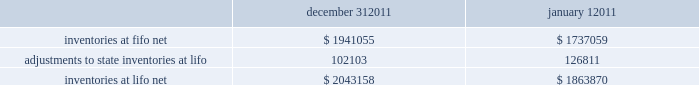Advance auto parts , inc .
And subsidiaries notes to the consolidated financial statements december 31 , 2011 , january 1 , 2011 and january 2 , 2010 ( in thousands , except per share data ) 2011-12 superseded certain pending paragraphs in asu 2011-05 201ccomprehensive income 2013 presentation of comprehensive income 201d to effectively defer only those changes in asu 2011-05 that related to the presentation of reclassification adjustments out of accumulated other comprehensive income .
The adoption of asu 2011-05 is not expected to have a material impact on the company 2019s consolidated financial condition , results of operations or cash flows .
In january 2010 , the fasb issued asu no .
2010-06 201cfair value measurements and disclosures 2013 improving disclosures about fair value measurements . 201d asu 2010-06 requires new disclosures for significant transfers in and out of level 1 and 2 of the fair value hierarchy and the activity within level 3 of the fair value hierarchy .
The updated guidance also clarifies existing disclosures regarding the level of disaggregation of assets or liabilities and the valuation techniques and inputs used to measure fair value .
The updated guidance is effective for interim and annual reporting periods beginning after december 15 , 2009 , with the exception of the new level 3 activity disclosures , which are effective for interim and annual reporting periods beginning after december 15 , 2010 .
The adoption of asu 2010-06 had no impact on the company 2019s consolidated financial condition , results of operations or cash flows .
Inventories , net : merchandise inventory the company used the lifo method of accounting for approximately 95% ( 95 % ) of inventories at december 31 , 2011 and january 1 , 2011 .
Under lifo , the company 2019s cost of sales reflects the costs of the most recently purchased inventories , while the inventory carrying balance represents the costs for inventories purchased in fiscal 2011 and prior years .
As a result of utilizing lifo , the company recorded an increase to cost of sales of $ 24708 for fiscal 2011 due to an increase in supply chain costs and inflationary pressures affecting certain product categories .
The company recorded a reduction to cost of sales of $ 29554 and $ 16040 for fiscal 2010 and 2009 , respectively .
Prior to fiscal 2011 , the company 2019s overall costs to acquire inventory for the same or similar products generally decreased historically as the company has been able to leverage its continued growth , execution of merchandise strategies and realization of supply chain efficiencies .
Product cores the remaining inventories are comprised of product cores , the non-consumable portion of certain parts and batteries , which are valued under the first-in , first-out ( "fifo" ) method .
Product cores are included as part of the company's merchandise costs and are either passed on to the customer or returned to the vendor .
Because product cores are not subject to frequent cost changes like the company's other merchandise inventory , there is no material difference when applying either the lifo or fifo valuation method .
Inventory overhead costs purchasing and warehousing costs included in inventory , at fifo , at december 31 , 2011 and january 1 , 2011 , were $ 126840 and $ 103989 , respectively .
Inventory balance and inventory reserves inventory balances at year-end for fiscal 2011 and 2010 were as follows : inventories at fifo , net adjustments to state inventories at lifo inventories at lifo , net december 31 , $ 1941055 102103 $ 2043158 january 1 , $ 1737059 126811 $ 1863870 .
Advance auto parts , inc .
And subsidiaries notes to the consolidated financial statements december 31 , 2011 , january 1 , 2011 and january 2 , 2010 ( in thousands , except per share data ) 2011-12 superseded certain pending paragraphs in asu 2011-05 201ccomprehensive income 2013 presentation of comprehensive income 201d to effectively defer only those changes in asu 2011-05 that related to the presentation of reclassification adjustments out of accumulated other comprehensive income .
The adoption of asu 2011-05 is not expected to have a material impact on the company 2019s consolidated financial condition , results of operations or cash flows .
In january 2010 , the fasb issued asu no .
2010-06 201cfair value measurements and disclosures 2013 improving disclosures about fair value measurements . 201d asu 2010-06 requires new disclosures for significant transfers in and out of level 1 and 2 of the fair value hierarchy and the activity within level 3 of the fair value hierarchy .
The updated guidance also clarifies existing disclosures regarding the level of disaggregation of assets or liabilities and the valuation techniques and inputs used to measure fair value .
The updated guidance is effective for interim and annual reporting periods beginning after december 15 , 2009 , with the exception of the new level 3 activity disclosures , which are effective for interim and annual reporting periods beginning after december 15 , 2010 .
The adoption of asu 2010-06 had no impact on the company 2019s consolidated financial condition , results of operations or cash flows .
Inventories , net : merchandise inventory the company used the lifo method of accounting for approximately 95% ( 95 % ) of inventories at december 31 , 2011 and january 1 , 2011 .
Under lifo , the company 2019s cost of sales reflects the costs of the most recently purchased inventories , while the inventory carrying balance represents the costs for inventories purchased in fiscal 2011 and prior years .
As a result of utilizing lifo , the company recorded an increase to cost of sales of $ 24708 for fiscal 2011 due to an increase in supply chain costs and inflationary pressures affecting certain product categories .
The company recorded a reduction to cost of sales of $ 29554 and $ 16040 for fiscal 2010 and 2009 , respectively .
Prior to fiscal 2011 , the company 2019s overall costs to acquire inventory for the same or similar products generally decreased historically as the company has been able to leverage its continued growth , execution of merchandise strategies and realization of supply chain efficiencies .
Product cores the remaining inventories are comprised of product cores , the non-consumable portion of certain parts and batteries , which are valued under the first-in , first-out ( "fifo" ) method .
Product cores are included as part of the company's merchandise costs and are either passed on to the customer or returned to the vendor .
Because product cores are not subject to frequent cost changes like the company's other merchandise inventory , there is no material difference when applying either the lifo or fifo valuation method .
Inventory overhead costs purchasing and warehousing costs included in inventory , at fifo , at december 31 , 2011 and january 1 , 2011 , were $ 126840 and $ 103989 , respectively .
Inventory balance and inventory reserves inventory balances at year-end for fiscal 2011 and 2010 were as follows : inventories at fifo , net adjustments to state inventories at lifo inventories at lifo , net december 31 , $ 1941055 102103 $ 2043158 january 1 , $ 1737059 126811 $ 1863870 .
How is the cashflow from operations affected by the change in inventories at fifo net? 
Computations: (1737059 - 1941055)
Answer: -203996.0. 